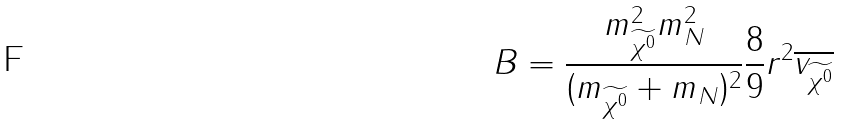Convert formula to latex. <formula><loc_0><loc_0><loc_500><loc_500>B = \frac { m ^ { 2 } _ { \widetilde { \chi ^ { 0 } } } m ^ { 2 } _ { N } } { ( m _ { \widetilde { \chi ^ { 0 } } } + m _ { N } ) ^ { 2 } } \frac { 8 } { 9 } r ^ { 2 } \overline { v _ { \widetilde { \chi ^ { 0 } } } }</formula> 